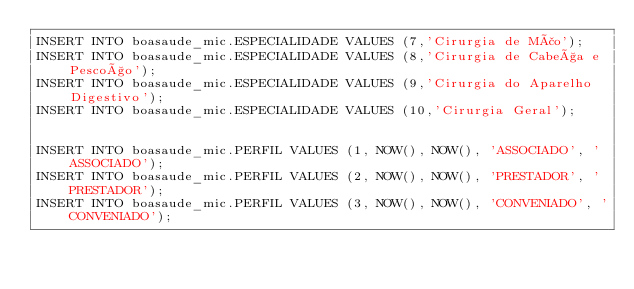<code> <loc_0><loc_0><loc_500><loc_500><_SQL_>INSERT INTO boasaude_mic.ESPECIALIDADE VALUES (7,'Cirurgia de Mão');
INSERT INTO boasaude_mic.ESPECIALIDADE VALUES (8,'Cirurgia de Cabeça e Pescoço');
INSERT INTO boasaude_mic.ESPECIALIDADE VALUES (9,'Cirurgia do Aparelho Digestivo');
INSERT INTO boasaude_mic.ESPECIALIDADE VALUES (10,'Cirurgia Geral');


INSERT INTO boasaude_mic.PERFIL VALUES (1, NOW(), NOW(), 'ASSOCIADO', 'ASSOCIADO');
INSERT INTO boasaude_mic.PERFIL VALUES (2, NOW(), NOW(), 'PRESTADOR', 'PRESTADOR');
INSERT INTO boasaude_mic.PERFIL VALUES (3, NOW(), NOW(), 'CONVENIADO', 'CONVENIADO');
</code> 